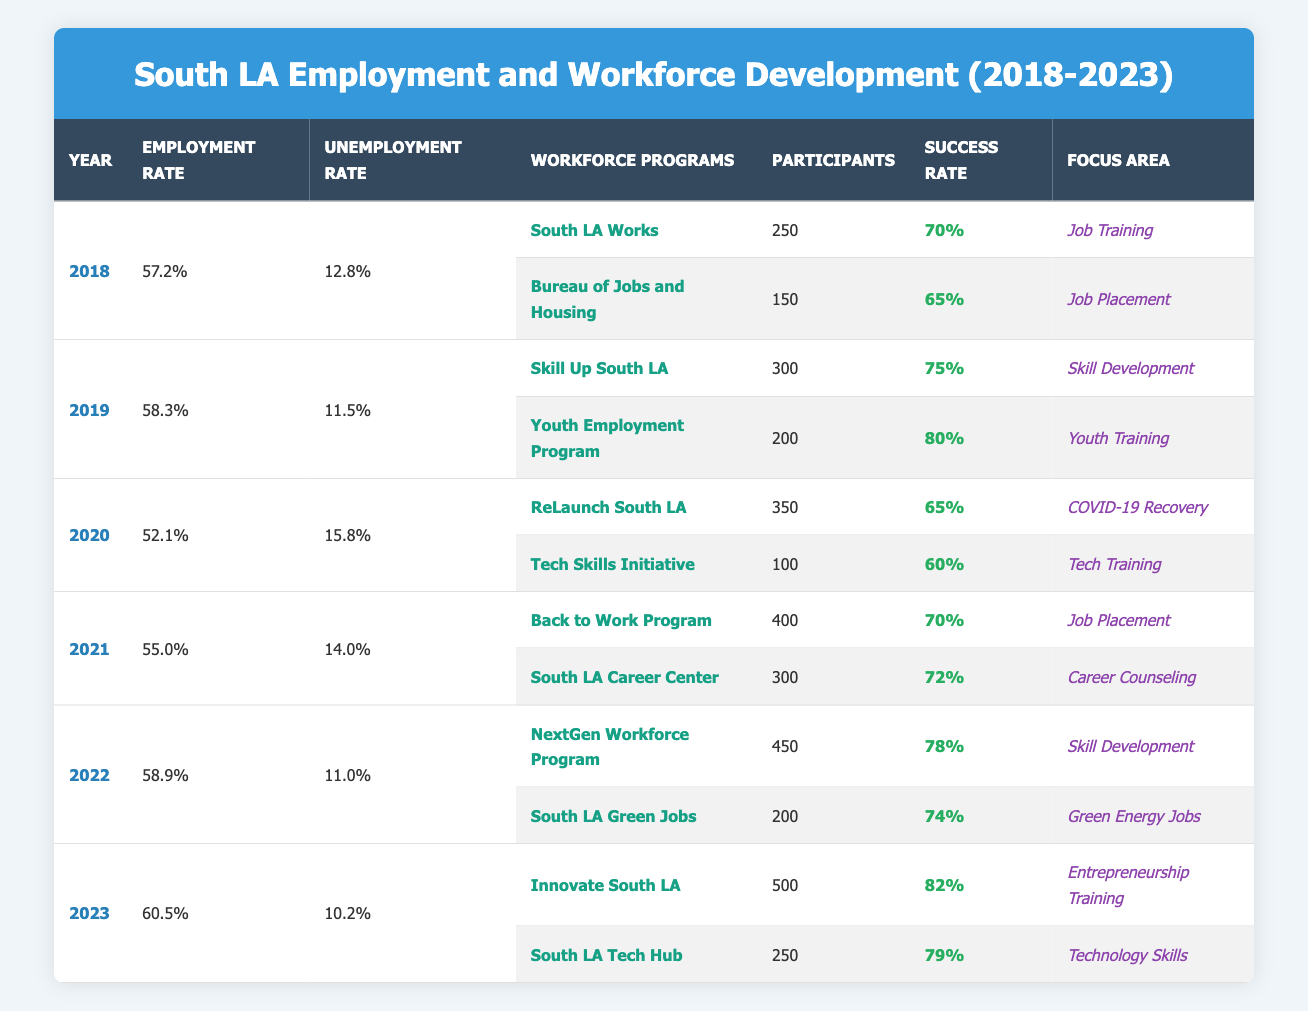What was the employment rate in South Los Angeles in 2021? According to the table, the employment rate for the year 2021 is listed as 55.0%.
Answer: 55.0% What is the success rate of the "NextGen Workforce Program"? From the table, the success rate for the "NextGen Workforce Program" is indicated as 78%.
Answer: 78% How many participants were in the "ReLaunch South LA" program in 2020? The table shows that in 2020, the "ReLaunch South LA" program had 350 participants.
Answer: 350 What was the change in unemployment rate from 2018 to 2023? For 2018, the unemployment rate is 12.8% and for 2023 it is 10.2%. The change is 12.8% - 10.2% = 2.6%.
Answer: 2.6% Which year had the highest employment rate and what was that rate? Looking at the employment rates from 2018 to 2023, 2023 shows the highest employment rate at 60.5%.
Answer: 60.5% Did the "Youth Employment Program" have more participants than the "South LA Green Jobs" program in 2022? In 2022, the "Youth Employment Program" had 200 participants and the "South LA Green Jobs" had 200 participants as well. Therefore, they are equal, not more.
Answer: No What is the average success rate of workforce programs in 2019? There are two programs in 2019: "Skill Up South LA" with a success rate of 75% and "Youth Employment Program" with a success rate of 80%. The average is (75% + 80%)/2 = 77.5%.
Answer: 77.5% Which program had the highest success rate in 2023? In 2023, the "Innovate South LA" program had a success rate of 82%, which is higher than "South LA Tech Hub" at 79%.
Answer: Innovate South LA Has the unemployment rate decreased every year from 2018 to 2023? The unemployment rates are as follows: 12.8% (2018), 11.5% (2019), 15.8% (2020), 14.0% (2021), 11.0% (2022), and 10.2% (2023). There is an increase in 2020 and 2021, confirming that it did not decrease every year.
Answer: No 